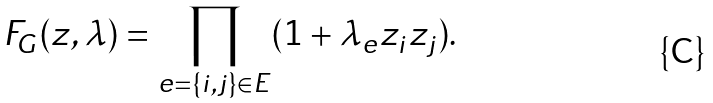Convert formula to latex. <formula><loc_0><loc_0><loc_500><loc_500>F _ { G } ( z , \lambda ) = \prod _ { e = \{ i , j \} \in E } ( 1 + \lambda _ { e } z _ { i } z _ { j } ) .</formula> 